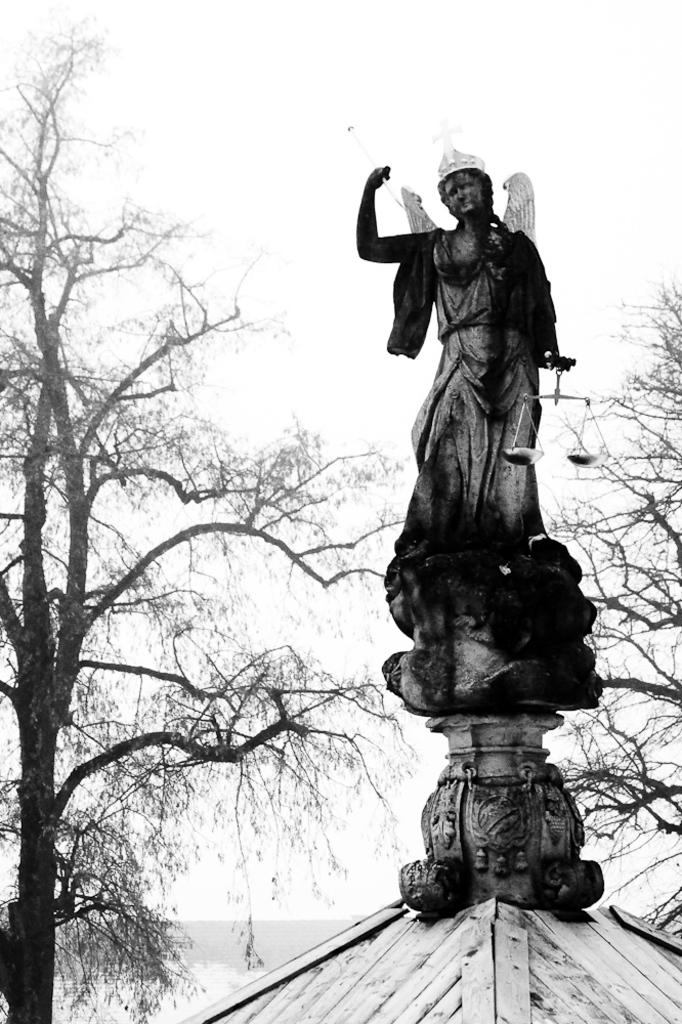What is the main subject in the image? There is a sculpture in the image. What other elements can be seen in the image besides the sculpture? There are trees in the image. What can be seen in the background of the image? The sky is visible in the background of the image. What type of voyage is depicted in the image? There is no voyage depicted in the image; it features a sculpture and trees with the sky visible in the background. How many snakes are present in the image? There are no snakes present in the image. 